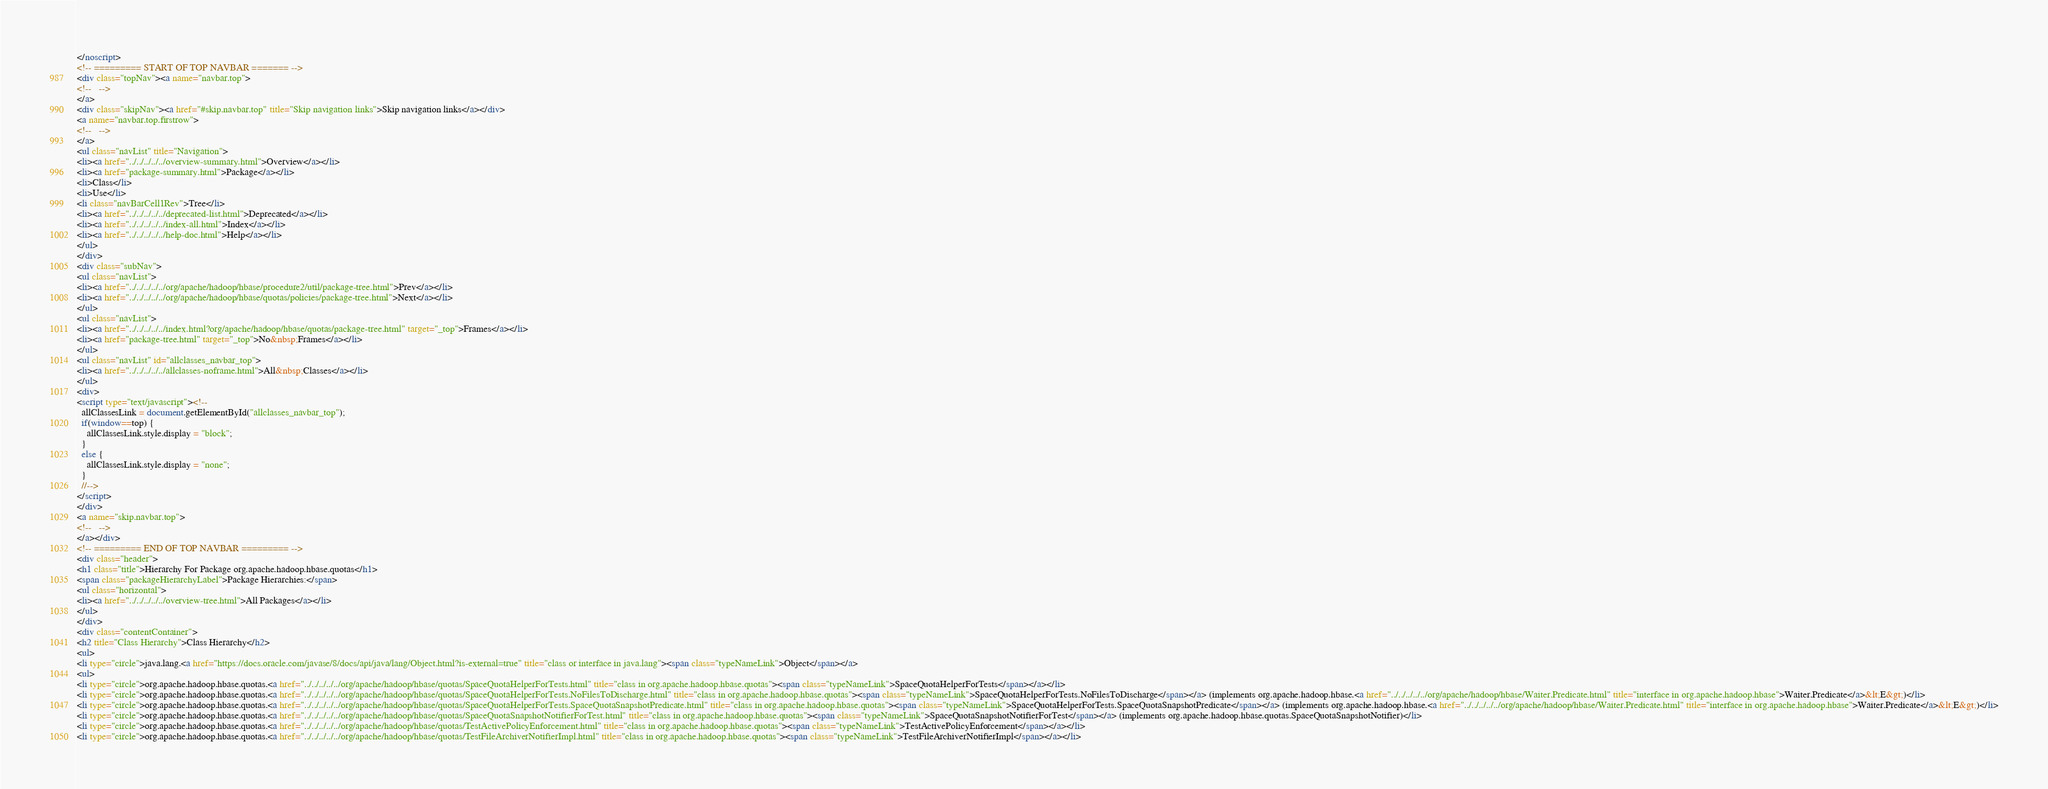Convert code to text. <code><loc_0><loc_0><loc_500><loc_500><_HTML_></noscript>
<!-- ========= START OF TOP NAVBAR ======= -->
<div class="topNav"><a name="navbar.top">
<!--   -->
</a>
<div class="skipNav"><a href="#skip.navbar.top" title="Skip navigation links">Skip navigation links</a></div>
<a name="navbar.top.firstrow">
<!--   -->
</a>
<ul class="navList" title="Navigation">
<li><a href="../../../../../overview-summary.html">Overview</a></li>
<li><a href="package-summary.html">Package</a></li>
<li>Class</li>
<li>Use</li>
<li class="navBarCell1Rev">Tree</li>
<li><a href="../../../../../deprecated-list.html">Deprecated</a></li>
<li><a href="../../../../../index-all.html">Index</a></li>
<li><a href="../../../../../help-doc.html">Help</a></li>
</ul>
</div>
<div class="subNav">
<ul class="navList">
<li><a href="../../../../../org/apache/hadoop/hbase/procedure2/util/package-tree.html">Prev</a></li>
<li><a href="../../../../../org/apache/hadoop/hbase/quotas/policies/package-tree.html">Next</a></li>
</ul>
<ul class="navList">
<li><a href="../../../../../index.html?org/apache/hadoop/hbase/quotas/package-tree.html" target="_top">Frames</a></li>
<li><a href="package-tree.html" target="_top">No&nbsp;Frames</a></li>
</ul>
<ul class="navList" id="allclasses_navbar_top">
<li><a href="../../../../../allclasses-noframe.html">All&nbsp;Classes</a></li>
</ul>
<div>
<script type="text/javascript"><!--
  allClassesLink = document.getElementById("allclasses_navbar_top");
  if(window==top) {
    allClassesLink.style.display = "block";
  }
  else {
    allClassesLink.style.display = "none";
  }
  //-->
</script>
</div>
<a name="skip.navbar.top">
<!--   -->
</a></div>
<!-- ========= END OF TOP NAVBAR ========= -->
<div class="header">
<h1 class="title">Hierarchy For Package org.apache.hadoop.hbase.quotas</h1>
<span class="packageHierarchyLabel">Package Hierarchies:</span>
<ul class="horizontal">
<li><a href="../../../../../overview-tree.html">All Packages</a></li>
</ul>
</div>
<div class="contentContainer">
<h2 title="Class Hierarchy">Class Hierarchy</h2>
<ul>
<li type="circle">java.lang.<a href="https://docs.oracle.com/javase/8/docs/api/java/lang/Object.html?is-external=true" title="class or interface in java.lang"><span class="typeNameLink">Object</span></a>
<ul>
<li type="circle">org.apache.hadoop.hbase.quotas.<a href="../../../../../org/apache/hadoop/hbase/quotas/SpaceQuotaHelperForTests.html" title="class in org.apache.hadoop.hbase.quotas"><span class="typeNameLink">SpaceQuotaHelperForTests</span></a></li>
<li type="circle">org.apache.hadoop.hbase.quotas.<a href="../../../../../org/apache/hadoop/hbase/quotas/SpaceQuotaHelperForTests.NoFilesToDischarge.html" title="class in org.apache.hadoop.hbase.quotas"><span class="typeNameLink">SpaceQuotaHelperForTests.NoFilesToDischarge</span></a> (implements org.apache.hadoop.hbase.<a href="../../../../../org/apache/hadoop/hbase/Waiter.Predicate.html" title="interface in org.apache.hadoop.hbase">Waiter.Predicate</a>&lt;E&gt;)</li>
<li type="circle">org.apache.hadoop.hbase.quotas.<a href="../../../../../org/apache/hadoop/hbase/quotas/SpaceQuotaHelperForTests.SpaceQuotaSnapshotPredicate.html" title="class in org.apache.hadoop.hbase.quotas"><span class="typeNameLink">SpaceQuotaHelperForTests.SpaceQuotaSnapshotPredicate</span></a> (implements org.apache.hadoop.hbase.<a href="../../../../../org/apache/hadoop/hbase/Waiter.Predicate.html" title="interface in org.apache.hadoop.hbase">Waiter.Predicate</a>&lt;E&gt;)</li>
<li type="circle">org.apache.hadoop.hbase.quotas.<a href="../../../../../org/apache/hadoop/hbase/quotas/SpaceQuotaSnapshotNotifierForTest.html" title="class in org.apache.hadoop.hbase.quotas"><span class="typeNameLink">SpaceQuotaSnapshotNotifierForTest</span></a> (implements org.apache.hadoop.hbase.quotas.SpaceQuotaSnapshotNotifier)</li>
<li type="circle">org.apache.hadoop.hbase.quotas.<a href="../../../../../org/apache/hadoop/hbase/quotas/TestActivePolicyEnforcement.html" title="class in org.apache.hadoop.hbase.quotas"><span class="typeNameLink">TestActivePolicyEnforcement</span></a></li>
<li type="circle">org.apache.hadoop.hbase.quotas.<a href="../../../../../org/apache/hadoop/hbase/quotas/TestFileArchiverNotifierImpl.html" title="class in org.apache.hadoop.hbase.quotas"><span class="typeNameLink">TestFileArchiverNotifierImpl</span></a></li></code> 